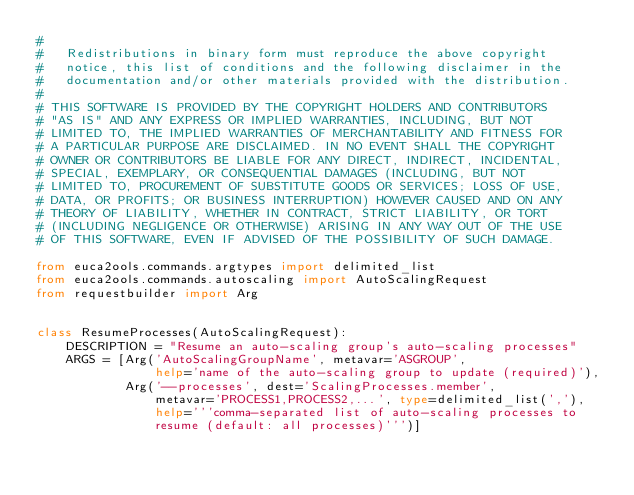Convert code to text. <code><loc_0><loc_0><loc_500><loc_500><_Python_>#
#   Redistributions in binary form must reproduce the above copyright
#   notice, this list of conditions and the following disclaimer in the
#   documentation and/or other materials provided with the distribution.
#
# THIS SOFTWARE IS PROVIDED BY THE COPYRIGHT HOLDERS AND CONTRIBUTORS
# "AS IS" AND ANY EXPRESS OR IMPLIED WARRANTIES, INCLUDING, BUT NOT
# LIMITED TO, THE IMPLIED WARRANTIES OF MERCHANTABILITY AND FITNESS FOR
# A PARTICULAR PURPOSE ARE DISCLAIMED. IN NO EVENT SHALL THE COPYRIGHT
# OWNER OR CONTRIBUTORS BE LIABLE FOR ANY DIRECT, INDIRECT, INCIDENTAL,
# SPECIAL, EXEMPLARY, OR CONSEQUENTIAL DAMAGES (INCLUDING, BUT NOT
# LIMITED TO, PROCUREMENT OF SUBSTITUTE GOODS OR SERVICES; LOSS OF USE,
# DATA, OR PROFITS; OR BUSINESS INTERRUPTION) HOWEVER CAUSED AND ON ANY
# THEORY OF LIABILITY, WHETHER IN CONTRACT, STRICT LIABILITY, OR TORT
# (INCLUDING NEGLIGENCE OR OTHERWISE) ARISING IN ANY WAY OUT OF THE USE
# OF THIS SOFTWARE, EVEN IF ADVISED OF THE POSSIBILITY OF SUCH DAMAGE.

from euca2ools.commands.argtypes import delimited_list
from euca2ools.commands.autoscaling import AutoScalingRequest
from requestbuilder import Arg


class ResumeProcesses(AutoScalingRequest):
    DESCRIPTION = "Resume an auto-scaling group's auto-scaling processes"
    ARGS = [Arg('AutoScalingGroupName', metavar='ASGROUP',
                help='name of the auto-scaling group to update (required)'),
            Arg('--processes', dest='ScalingProcesses.member',
                metavar='PROCESS1,PROCESS2,...', type=delimited_list(','),
                help='''comma-separated list of auto-scaling processes to
                resume (default: all processes)''')]
</code> 